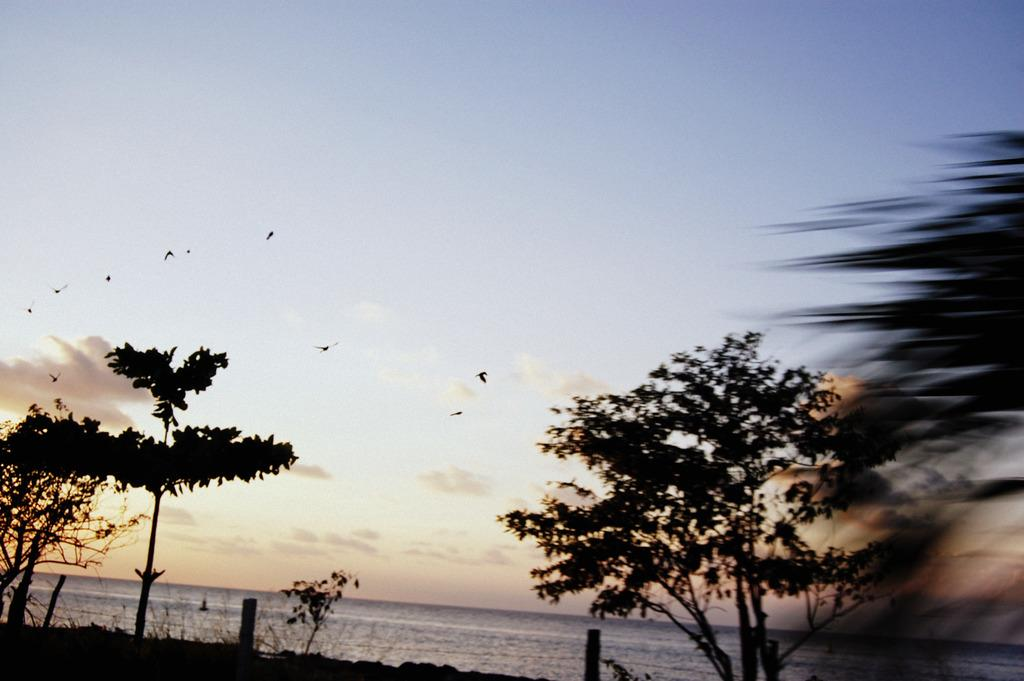What type of vegetation is on the right side of the image? There is a tree on the right side of the image. What type of vegetation is on the left side of the image? There are trees and plants on the left side of the image. What can be seen in the background of the image? Water, birds, the sky, and clouds are visible in the background of the image. Where is the book located in the image? There is no book present in the image. What type of cloud is depicted in the image? The provided facts do not specify the type of cloud; only that clouds are present in the background. --- Facts: 1. There is a car in the image. 2. The car is red. 3. The car has four wheels. 4. There is a road in the image. 5. The road is paved. Absurd Topics: parrot, ocean, mountain Conversation: What is the main subject of the image? The main subject of the image is a car. What color is the car? The car is red. How many wheels does the car have? The car has four wheels. What type of surface is the car on? There is a road in the image, and it is paved. Reasoning: Let's think step by step in order to produce the conversation. We start by identifying the main subject of the image, which is the car. Then, we describe specific features of the car, such as its color and the number of wheels. Finally, we describe the setting in which the car is located, noting that it is on a paved road. Absurd Question/Answer: Can you see a parrot flying over the ocean in the image? There is no parrot or ocean present in the image; it features a red car on a paved road. What type of mountain is visible in the background of the image? There is no mountain present in the image; it features a red car on a paved road. 